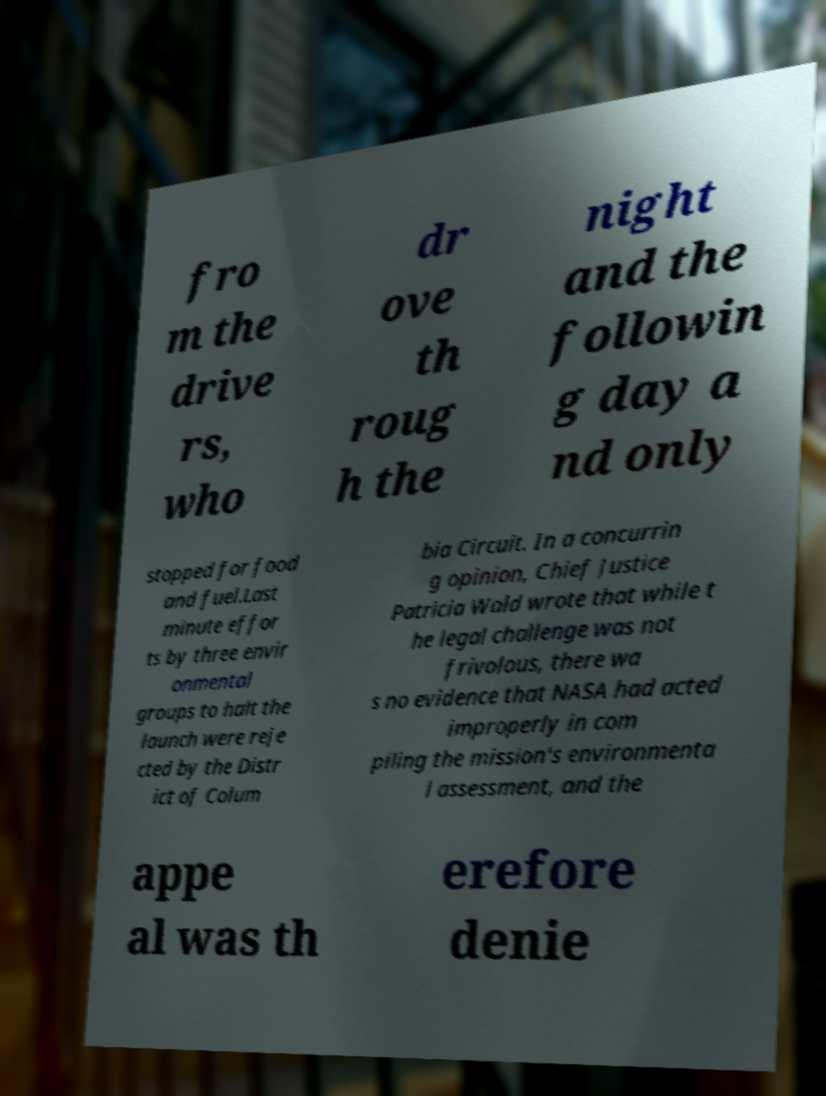Could you assist in decoding the text presented in this image and type it out clearly? fro m the drive rs, who dr ove th roug h the night and the followin g day a nd only stopped for food and fuel.Last minute effor ts by three envir onmental groups to halt the launch were reje cted by the Distr ict of Colum bia Circuit. In a concurrin g opinion, Chief Justice Patricia Wald wrote that while t he legal challenge was not frivolous, there wa s no evidence that NASA had acted improperly in com piling the mission's environmenta l assessment, and the appe al was th erefore denie 